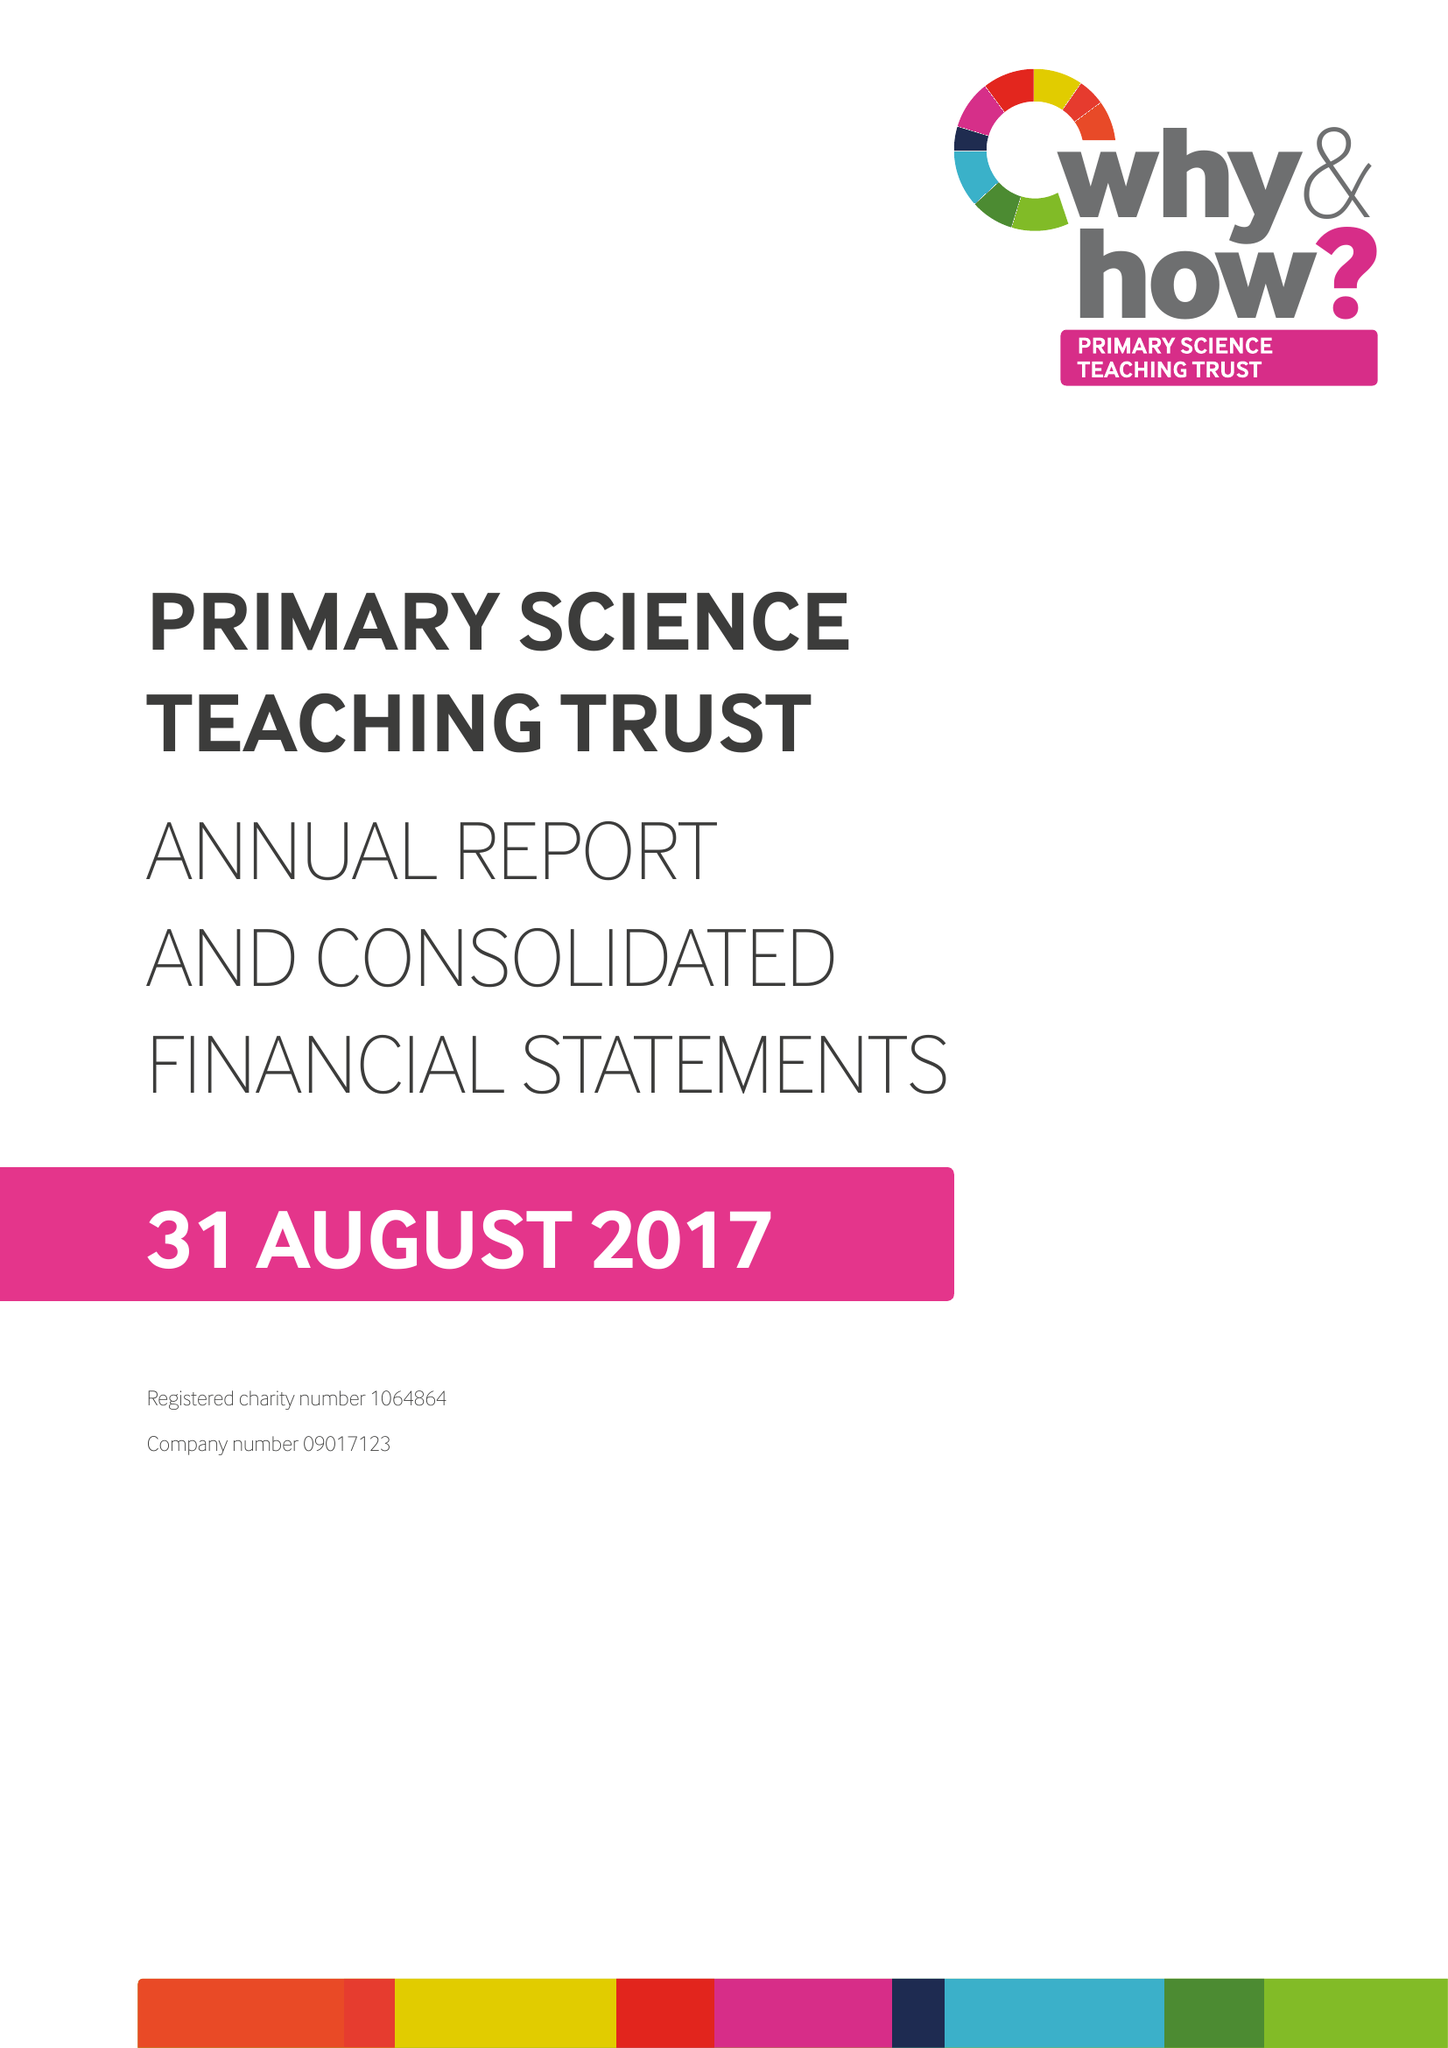What is the value for the report_date?
Answer the question using a single word or phrase. 2017-08-31 